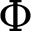Convert formula to latex. <formula><loc_0><loc_0><loc_500><loc_500>\Phi</formula> 